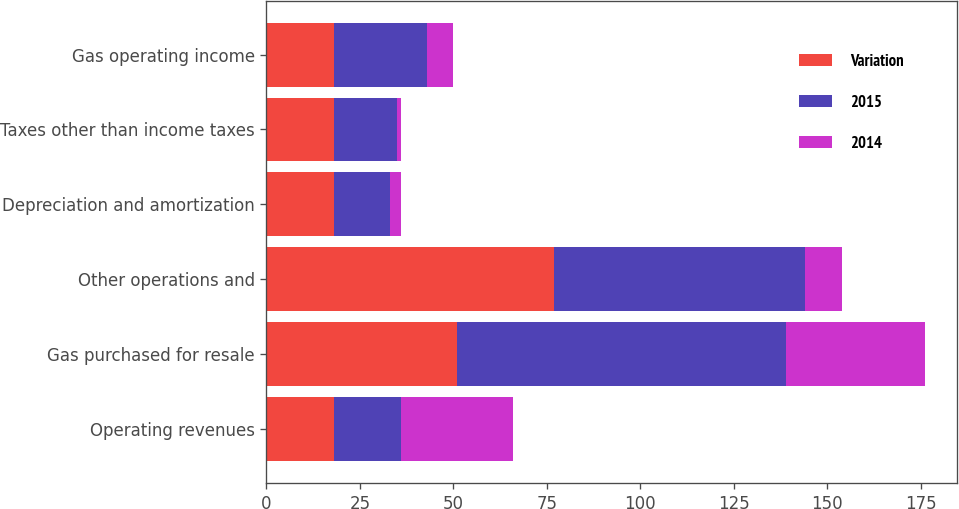Convert chart to OTSL. <chart><loc_0><loc_0><loc_500><loc_500><stacked_bar_chart><ecel><fcel>Operating revenues<fcel>Gas purchased for resale<fcel>Other operations and<fcel>Depreciation and amortization<fcel>Taxes other than income taxes<fcel>Gas operating income<nl><fcel>Variation<fcel>18<fcel>51<fcel>77<fcel>18<fcel>18<fcel>18<nl><fcel>2015<fcel>18<fcel>88<fcel>67<fcel>15<fcel>17<fcel>25<nl><fcel>2014<fcel>30<fcel>37<fcel>10<fcel>3<fcel>1<fcel>7<nl></chart> 